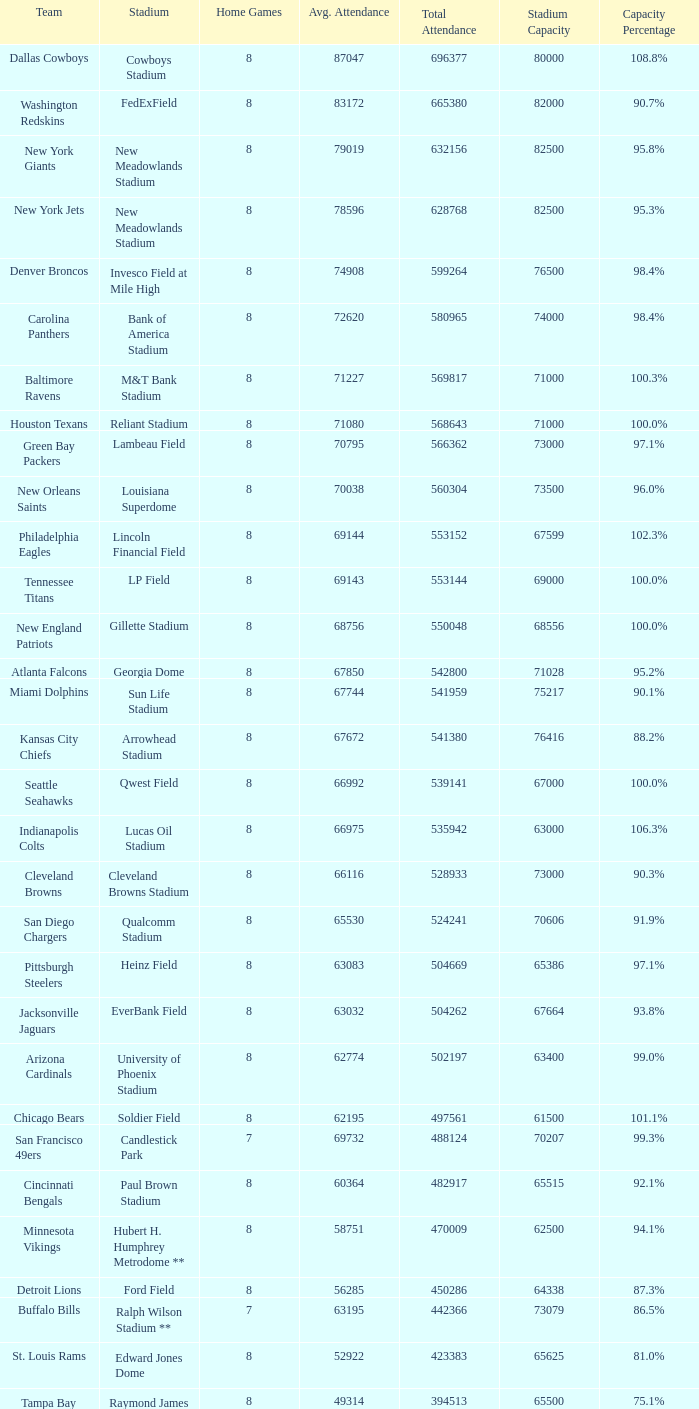What was the limit for the denver broncos? 98.4%. 